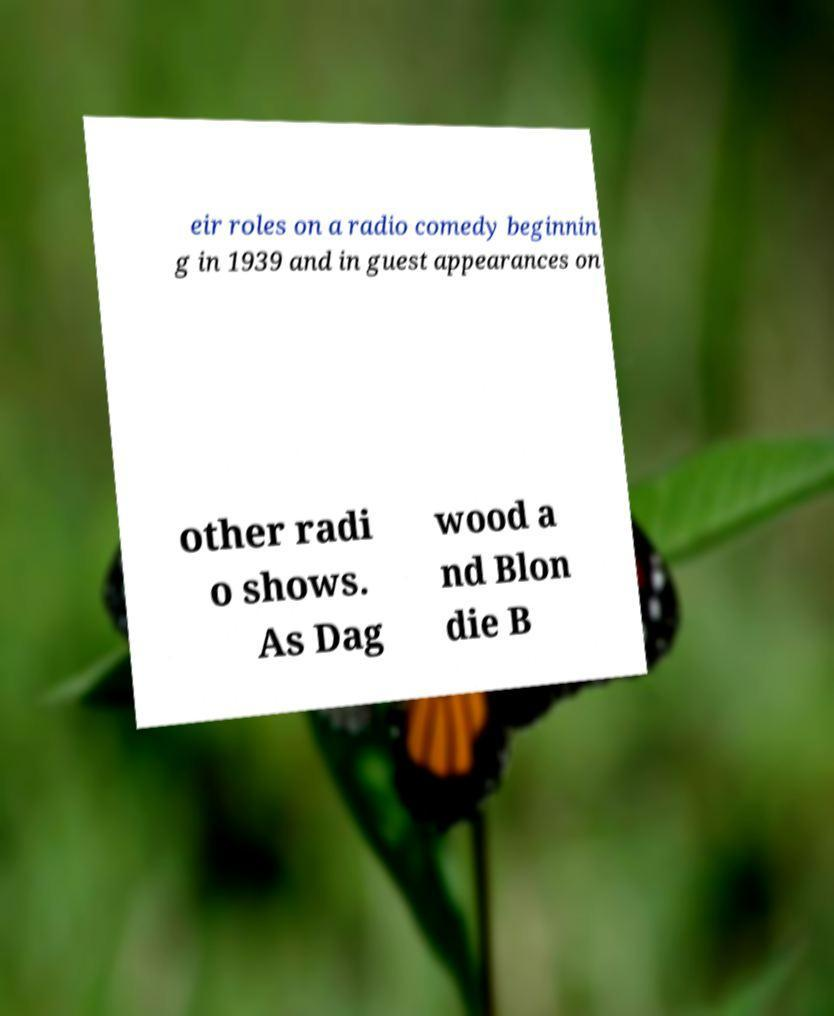Could you assist in decoding the text presented in this image and type it out clearly? eir roles on a radio comedy beginnin g in 1939 and in guest appearances on other radi o shows. As Dag wood a nd Blon die B 